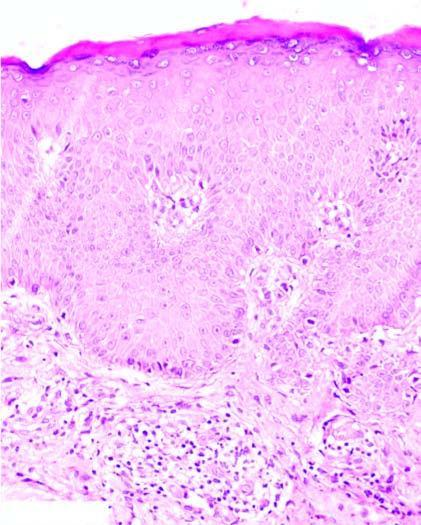what shows hyperkeratosis, acathosis and broadened papillae and spongiosis of the epidermal layers?
Answer the question using a single word or phrase. Epidermis 